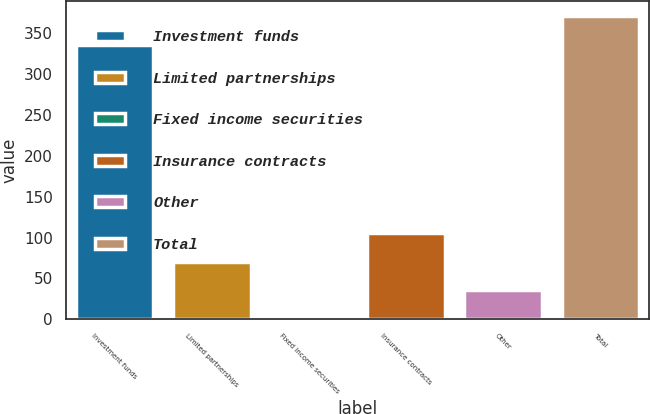Convert chart to OTSL. <chart><loc_0><loc_0><loc_500><loc_500><bar_chart><fcel>Investment funds<fcel>Limited partnerships<fcel>Fixed income securities<fcel>Insurance contracts<fcel>Other<fcel>Total<nl><fcel>335.8<fcel>70.3<fcel>0.4<fcel>105.25<fcel>35.35<fcel>370.75<nl></chart> 